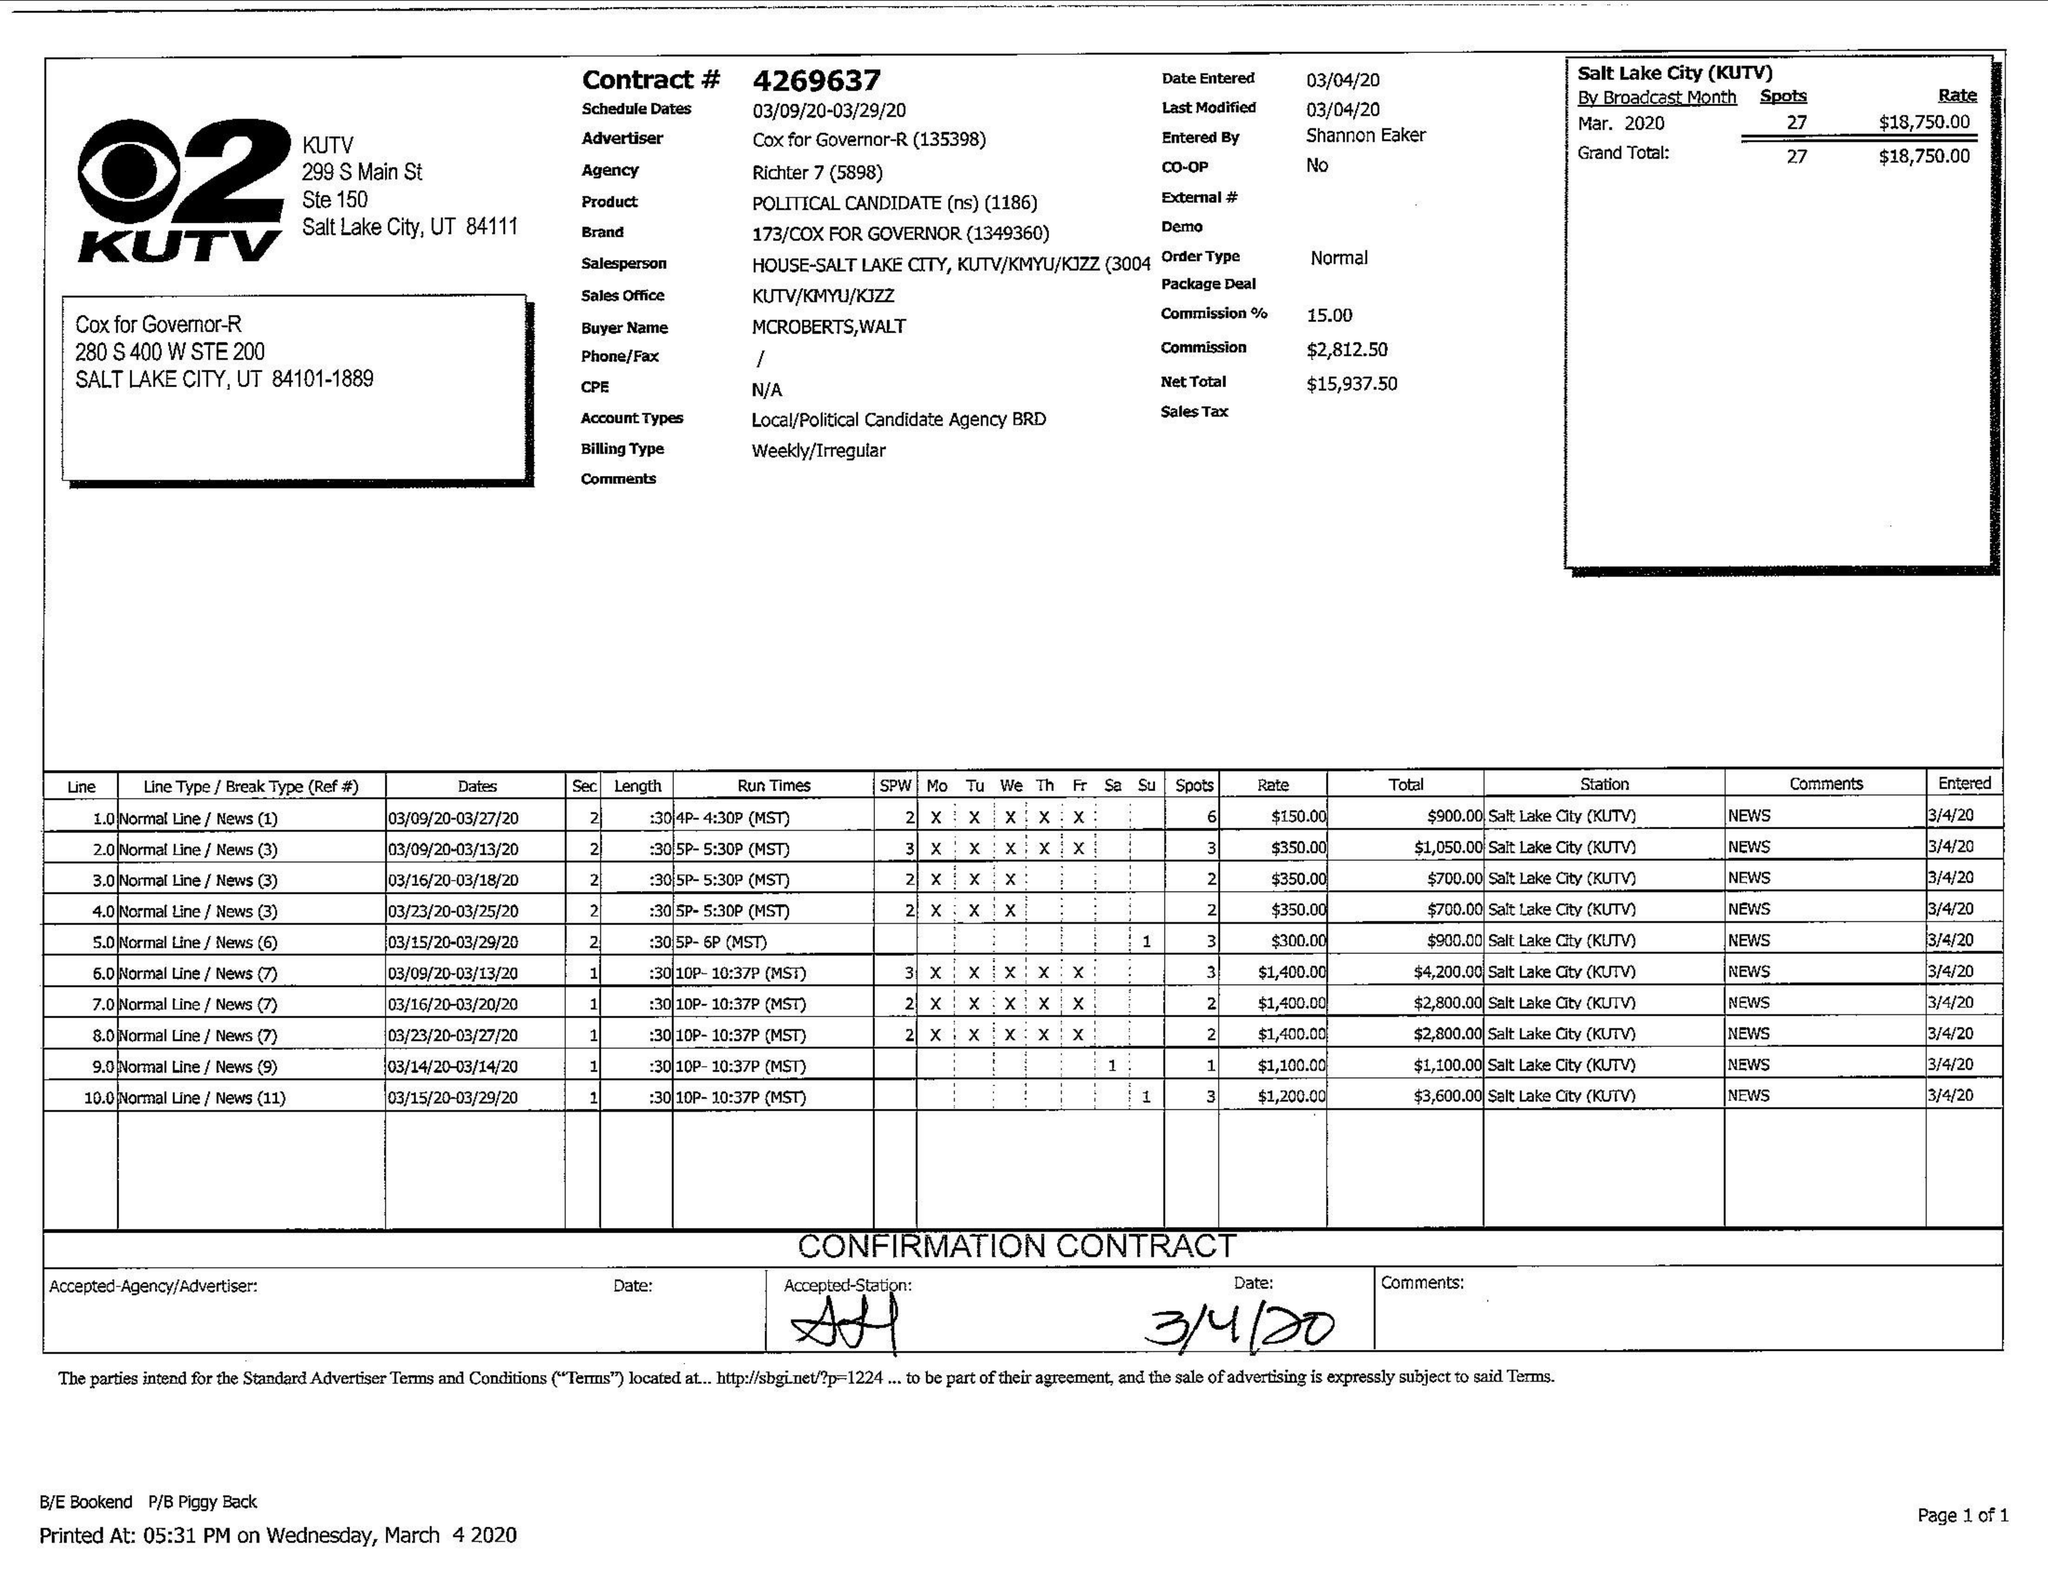What is the value for the contract_num?
Answer the question using a single word or phrase. 4269637 